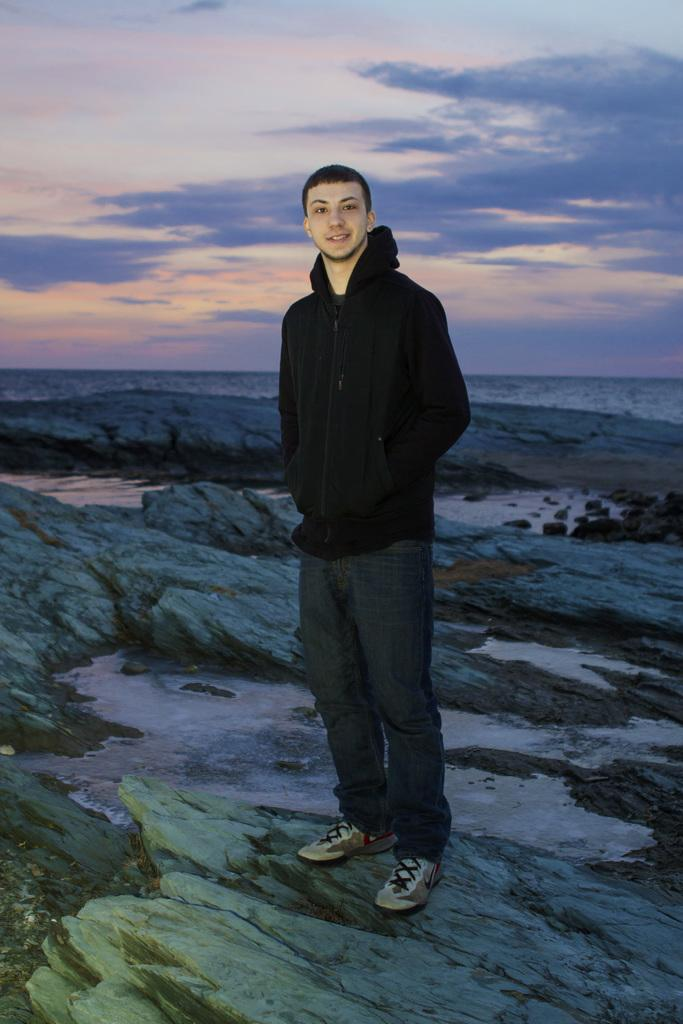Who is present in the image? There is a man in the image. What is the man doing in the image? The man is standing on a rock. What is the man wearing in the image? The man is wearing a black sweater. What can be seen in the background of the image? There are clouds visible in the background of the image. What type of drain is visible in the image? There is no drain present in the image. What emotion does the man appear to be experiencing in the image? The provided facts do not mention the man's emotions, so we cannot determine his emotional state from the image. 